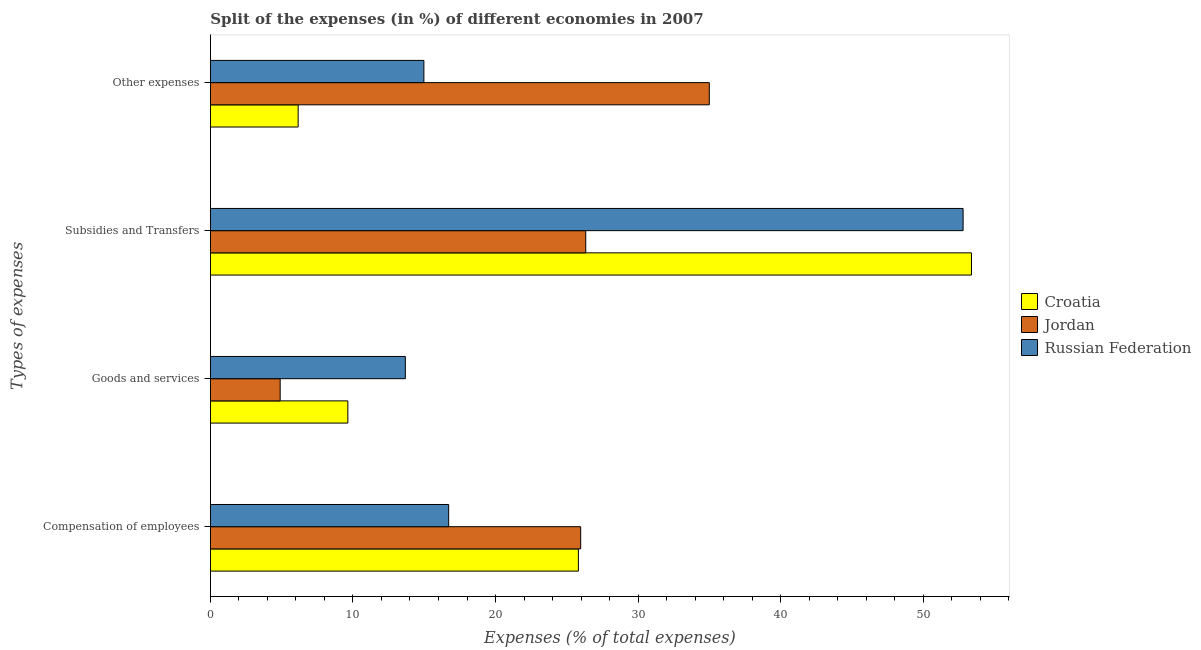How many different coloured bars are there?
Offer a very short reply. 3. How many bars are there on the 2nd tick from the top?
Provide a short and direct response. 3. How many bars are there on the 4th tick from the bottom?
Provide a short and direct response. 3. What is the label of the 1st group of bars from the top?
Give a very brief answer. Other expenses. What is the percentage of amount spent on goods and services in Jordan?
Your response must be concise. 4.89. Across all countries, what is the maximum percentage of amount spent on compensation of employees?
Offer a terse response. 25.97. Across all countries, what is the minimum percentage of amount spent on subsidies?
Ensure brevity in your answer.  26.33. In which country was the percentage of amount spent on subsidies maximum?
Ensure brevity in your answer.  Croatia. In which country was the percentage of amount spent on goods and services minimum?
Your answer should be very brief. Jordan. What is the total percentage of amount spent on goods and services in the graph?
Offer a very short reply. 28.21. What is the difference between the percentage of amount spent on compensation of employees in Jordan and that in Russian Federation?
Your answer should be very brief. 9.26. What is the difference between the percentage of amount spent on other expenses in Jordan and the percentage of amount spent on goods and services in Russian Federation?
Your answer should be compact. 21.32. What is the average percentage of amount spent on other expenses per country?
Keep it short and to the point. 18.71. What is the difference between the percentage of amount spent on goods and services and percentage of amount spent on other expenses in Croatia?
Your answer should be compact. 3.49. What is the ratio of the percentage of amount spent on other expenses in Russian Federation to that in Croatia?
Offer a very short reply. 2.43. Is the difference between the percentage of amount spent on other expenses in Russian Federation and Jordan greater than the difference between the percentage of amount spent on subsidies in Russian Federation and Jordan?
Your answer should be very brief. No. What is the difference between the highest and the second highest percentage of amount spent on compensation of employees?
Make the answer very short. 0.16. What is the difference between the highest and the lowest percentage of amount spent on compensation of employees?
Your response must be concise. 9.26. What does the 1st bar from the top in Other expenses represents?
Provide a succinct answer. Russian Federation. What does the 2nd bar from the bottom in Other expenses represents?
Ensure brevity in your answer.  Jordan. Where does the legend appear in the graph?
Your answer should be compact. Center right. How many legend labels are there?
Keep it short and to the point. 3. What is the title of the graph?
Keep it short and to the point. Split of the expenses (in %) of different economies in 2007. What is the label or title of the X-axis?
Offer a terse response. Expenses (% of total expenses). What is the label or title of the Y-axis?
Your answer should be compact. Types of expenses. What is the Expenses (% of total expenses) in Croatia in Compensation of employees?
Ensure brevity in your answer.  25.81. What is the Expenses (% of total expenses) in Jordan in Compensation of employees?
Your answer should be very brief. 25.97. What is the Expenses (% of total expenses) in Russian Federation in Compensation of employees?
Provide a succinct answer. 16.71. What is the Expenses (% of total expenses) of Croatia in Goods and services?
Your answer should be very brief. 9.64. What is the Expenses (% of total expenses) of Jordan in Goods and services?
Provide a short and direct response. 4.89. What is the Expenses (% of total expenses) in Russian Federation in Goods and services?
Keep it short and to the point. 13.67. What is the Expenses (% of total expenses) of Croatia in Subsidies and Transfers?
Ensure brevity in your answer.  53.38. What is the Expenses (% of total expenses) in Jordan in Subsidies and Transfers?
Your answer should be very brief. 26.33. What is the Expenses (% of total expenses) of Russian Federation in Subsidies and Transfers?
Give a very brief answer. 52.8. What is the Expenses (% of total expenses) in Croatia in Other expenses?
Your response must be concise. 6.16. What is the Expenses (% of total expenses) in Jordan in Other expenses?
Your answer should be very brief. 34.99. What is the Expenses (% of total expenses) of Russian Federation in Other expenses?
Make the answer very short. 14.98. Across all Types of expenses, what is the maximum Expenses (% of total expenses) in Croatia?
Make the answer very short. 53.38. Across all Types of expenses, what is the maximum Expenses (% of total expenses) of Jordan?
Give a very brief answer. 34.99. Across all Types of expenses, what is the maximum Expenses (% of total expenses) in Russian Federation?
Make the answer very short. 52.8. Across all Types of expenses, what is the minimum Expenses (% of total expenses) of Croatia?
Provide a short and direct response. 6.16. Across all Types of expenses, what is the minimum Expenses (% of total expenses) in Jordan?
Give a very brief answer. 4.89. Across all Types of expenses, what is the minimum Expenses (% of total expenses) of Russian Federation?
Offer a very short reply. 13.67. What is the total Expenses (% of total expenses) of Croatia in the graph?
Keep it short and to the point. 94.99. What is the total Expenses (% of total expenses) of Jordan in the graph?
Your response must be concise. 92.19. What is the total Expenses (% of total expenses) of Russian Federation in the graph?
Ensure brevity in your answer.  98.16. What is the difference between the Expenses (% of total expenses) of Croatia in Compensation of employees and that in Goods and services?
Your response must be concise. 16.17. What is the difference between the Expenses (% of total expenses) of Jordan in Compensation of employees and that in Goods and services?
Offer a very short reply. 21.08. What is the difference between the Expenses (% of total expenses) of Russian Federation in Compensation of employees and that in Goods and services?
Offer a very short reply. 3.04. What is the difference between the Expenses (% of total expenses) in Croatia in Compensation of employees and that in Subsidies and Transfers?
Your response must be concise. -27.57. What is the difference between the Expenses (% of total expenses) of Jordan in Compensation of employees and that in Subsidies and Transfers?
Give a very brief answer. -0.36. What is the difference between the Expenses (% of total expenses) in Russian Federation in Compensation of employees and that in Subsidies and Transfers?
Your answer should be very brief. -36.08. What is the difference between the Expenses (% of total expenses) in Croatia in Compensation of employees and that in Other expenses?
Offer a terse response. 19.66. What is the difference between the Expenses (% of total expenses) in Jordan in Compensation of employees and that in Other expenses?
Ensure brevity in your answer.  -9.02. What is the difference between the Expenses (% of total expenses) of Russian Federation in Compensation of employees and that in Other expenses?
Offer a very short reply. 1.74. What is the difference between the Expenses (% of total expenses) of Croatia in Goods and services and that in Subsidies and Transfers?
Ensure brevity in your answer.  -43.74. What is the difference between the Expenses (% of total expenses) of Jordan in Goods and services and that in Subsidies and Transfers?
Make the answer very short. -21.43. What is the difference between the Expenses (% of total expenses) of Russian Federation in Goods and services and that in Subsidies and Transfers?
Offer a terse response. -39.12. What is the difference between the Expenses (% of total expenses) of Croatia in Goods and services and that in Other expenses?
Offer a very short reply. 3.49. What is the difference between the Expenses (% of total expenses) in Jordan in Goods and services and that in Other expenses?
Ensure brevity in your answer.  -30.1. What is the difference between the Expenses (% of total expenses) in Russian Federation in Goods and services and that in Other expenses?
Offer a very short reply. -1.3. What is the difference between the Expenses (% of total expenses) of Croatia in Subsidies and Transfers and that in Other expenses?
Your response must be concise. 47.23. What is the difference between the Expenses (% of total expenses) of Jordan in Subsidies and Transfers and that in Other expenses?
Give a very brief answer. -8.67. What is the difference between the Expenses (% of total expenses) in Russian Federation in Subsidies and Transfers and that in Other expenses?
Keep it short and to the point. 37.82. What is the difference between the Expenses (% of total expenses) of Croatia in Compensation of employees and the Expenses (% of total expenses) of Jordan in Goods and services?
Provide a short and direct response. 20.92. What is the difference between the Expenses (% of total expenses) in Croatia in Compensation of employees and the Expenses (% of total expenses) in Russian Federation in Goods and services?
Make the answer very short. 12.14. What is the difference between the Expenses (% of total expenses) of Jordan in Compensation of employees and the Expenses (% of total expenses) of Russian Federation in Goods and services?
Offer a terse response. 12.3. What is the difference between the Expenses (% of total expenses) in Croatia in Compensation of employees and the Expenses (% of total expenses) in Jordan in Subsidies and Transfers?
Your answer should be compact. -0.52. What is the difference between the Expenses (% of total expenses) of Croatia in Compensation of employees and the Expenses (% of total expenses) of Russian Federation in Subsidies and Transfers?
Your answer should be very brief. -26.98. What is the difference between the Expenses (% of total expenses) in Jordan in Compensation of employees and the Expenses (% of total expenses) in Russian Federation in Subsidies and Transfers?
Offer a very short reply. -26.82. What is the difference between the Expenses (% of total expenses) of Croatia in Compensation of employees and the Expenses (% of total expenses) of Jordan in Other expenses?
Offer a very short reply. -9.18. What is the difference between the Expenses (% of total expenses) in Croatia in Compensation of employees and the Expenses (% of total expenses) in Russian Federation in Other expenses?
Offer a very short reply. 10.84. What is the difference between the Expenses (% of total expenses) in Jordan in Compensation of employees and the Expenses (% of total expenses) in Russian Federation in Other expenses?
Provide a succinct answer. 11. What is the difference between the Expenses (% of total expenses) of Croatia in Goods and services and the Expenses (% of total expenses) of Jordan in Subsidies and Transfers?
Offer a terse response. -16.69. What is the difference between the Expenses (% of total expenses) of Croatia in Goods and services and the Expenses (% of total expenses) of Russian Federation in Subsidies and Transfers?
Provide a succinct answer. -43.16. What is the difference between the Expenses (% of total expenses) in Jordan in Goods and services and the Expenses (% of total expenses) in Russian Federation in Subsidies and Transfers?
Provide a short and direct response. -47.9. What is the difference between the Expenses (% of total expenses) in Croatia in Goods and services and the Expenses (% of total expenses) in Jordan in Other expenses?
Provide a succinct answer. -25.35. What is the difference between the Expenses (% of total expenses) in Croatia in Goods and services and the Expenses (% of total expenses) in Russian Federation in Other expenses?
Your response must be concise. -5.33. What is the difference between the Expenses (% of total expenses) of Jordan in Goods and services and the Expenses (% of total expenses) of Russian Federation in Other expenses?
Your answer should be compact. -10.08. What is the difference between the Expenses (% of total expenses) of Croatia in Subsidies and Transfers and the Expenses (% of total expenses) of Jordan in Other expenses?
Provide a succinct answer. 18.39. What is the difference between the Expenses (% of total expenses) in Croatia in Subsidies and Transfers and the Expenses (% of total expenses) in Russian Federation in Other expenses?
Give a very brief answer. 38.41. What is the difference between the Expenses (% of total expenses) in Jordan in Subsidies and Transfers and the Expenses (% of total expenses) in Russian Federation in Other expenses?
Provide a succinct answer. 11.35. What is the average Expenses (% of total expenses) of Croatia per Types of expenses?
Your response must be concise. 23.75. What is the average Expenses (% of total expenses) in Jordan per Types of expenses?
Provide a succinct answer. 23.05. What is the average Expenses (% of total expenses) in Russian Federation per Types of expenses?
Provide a short and direct response. 24.54. What is the difference between the Expenses (% of total expenses) in Croatia and Expenses (% of total expenses) in Jordan in Compensation of employees?
Provide a short and direct response. -0.16. What is the difference between the Expenses (% of total expenses) in Croatia and Expenses (% of total expenses) in Russian Federation in Compensation of employees?
Make the answer very short. 9.1. What is the difference between the Expenses (% of total expenses) in Jordan and Expenses (% of total expenses) in Russian Federation in Compensation of employees?
Provide a succinct answer. 9.26. What is the difference between the Expenses (% of total expenses) in Croatia and Expenses (% of total expenses) in Jordan in Goods and services?
Your answer should be very brief. 4.75. What is the difference between the Expenses (% of total expenses) of Croatia and Expenses (% of total expenses) of Russian Federation in Goods and services?
Your response must be concise. -4.03. What is the difference between the Expenses (% of total expenses) of Jordan and Expenses (% of total expenses) of Russian Federation in Goods and services?
Offer a terse response. -8.78. What is the difference between the Expenses (% of total expenses) of Croatia and Expenses (% of total expenses) of Jordan in Subsidies and Transfers?
Ensure brevity in your answer.  27.05. What is the difference between the Expenses (% of total expenses) in Croatia and Expenses (% of total expenses) in Russian Federation in Subsidies and Transfers?
Make the answer very short. 0.59. What is the difference between the Expenses (% of total expenses) in Jordan and Expenses (% of total expenses) in Russian Federation in Subsidies and Transfers?
Offer a terse response. -26.47. What is the difference between the Expenses (% of total expenses) in Croatia and Expenses (% of total expenses) in Jordan in Other expenses?
Provide a short and direct response. -28.84. What is the difference between the Expenses (% of total expenses) of Croatia and Expenses (% of total expenses) of Russian Federation in Other expenses?
Make the answer very short. -8.82. What is the difference between the Expenses (% of total expenses) in Jordan and Expenses (% of total expenses) in Russian Federation in Other expenses?
Provide a succinct answer. 20.02. What is the ratio of the Expenses (% of total expenses) in Croatia in Compensation of employees to that in Goods and services?
Give a very brief answer. 2.68. What is the ratio of the Expenses (% of total expenses) of Jordan in Compensation of employees to that in Goods and services?
Provide a short and direct response. 5.31. What is the ratio of the Expenses (% of total expenses) in Russian Federation in Compensation of employees to that in Goods and services?
Your response must be concise. 1.22. What is the ratio of the Expenses (% of total expenses) of Croatia in Compensation of employees to that in Subsidies and Transfers?
Your answer should be compact. 0.48. What is the ratio of the Expenses (% of total expenses) in Jordan in Compensation of employees to that in Subsidies and Transfers?
Keep it short and to the point. 0.99. What is the ratio of the Expenses (% of total expenses) of Russian Federation in Compensation of employees to that in Subsidies and Transfers?
Give a very brief answer. 0.32. What is the ratio of the Expenses (% of total expenses) of Croatia in Compensation of employees to that in Other expenses?
Your answer should be very brief. 4.19. What is the ratio of the Expenses (% of total expenses) in Jordan in Compensation of employees to that in Other expenses?
Your response must be concise. 0.74. What is the ratio of the Expenses (% of total expenses) in Russian Federation in Compensation of employees to that in Other expenses?
Ensure brevity in your answer.  1.12. What is the ratio of the Expenses (% of total expenses) of Croatia in Goods and services to that in Subsidies and Transfers?
Your answer should be very brief. 0.18. What is the ratio of the Expenses (% of total expenses) of Jordan in Goods and services to that in Subsidies and Transfers?
Make the answer very short. 0.19. What is the ratio of the Expenses (% of total expenses) of Russian Federation in Goods and services to that in Subsidies and Transfers?
Keep it short and to the point. 0.26. What is the ratio of the Expenses (% of total expenses) of Croatia in Goods and services to that in Other expenses?
Your answer should be compact. 1.57. What is the ratio of the Expenses (% of total expenses) of Jordan in Goods and services to that in Other expenses?
Your response must be concise. 0.14. What is the ratio of the Expenses (% of total expenses) in Russian Federation in Goods and services to that in Other expenses?
Give a very brief answer. 0.91. What is the ratio of the Expenses (% of total expenses) of Croatia in Subsidies and Transfers to that in Other expenses?
Give a very brief answer. 8.67. What is the ratio of the Expenses (% of total expenses) in Jordan in Subsidies and Transfers to that in Other expenses?
Keep it short and to the point. 0.75. What is the ratio of the Expenses (% of total expenses) in Russian Federation in Subsidies and Transfers to that in Other expenses?
Make the answer very short. 3.53. What is the difference between the highest and the second highest Expenses (% of total expenses) of Croatia?
Make the answer very short. 27.57. What is the difference between the highest and the second highest Expenses (% of total expenses) of Jordan?
Your answer should be very brief. 8.67. What is the difference between the highest and the second highest Expenses (% of total expenses) of Russian Federation?
Provide a short and direct response. 36.08. What is the difference between the highest and the lowest Expenses (% of total expenses) in Croatia?
Give a very brief answer. 47.23. What is the difference between the highest and the lowest Expenses (% of total expenses) of Jordan?
Offer a terse response. 30.1. What is the difference between the highest and the lowest Expenses (% of total expenses) in Russian Federation?
Offer a terse response. 39.12. 